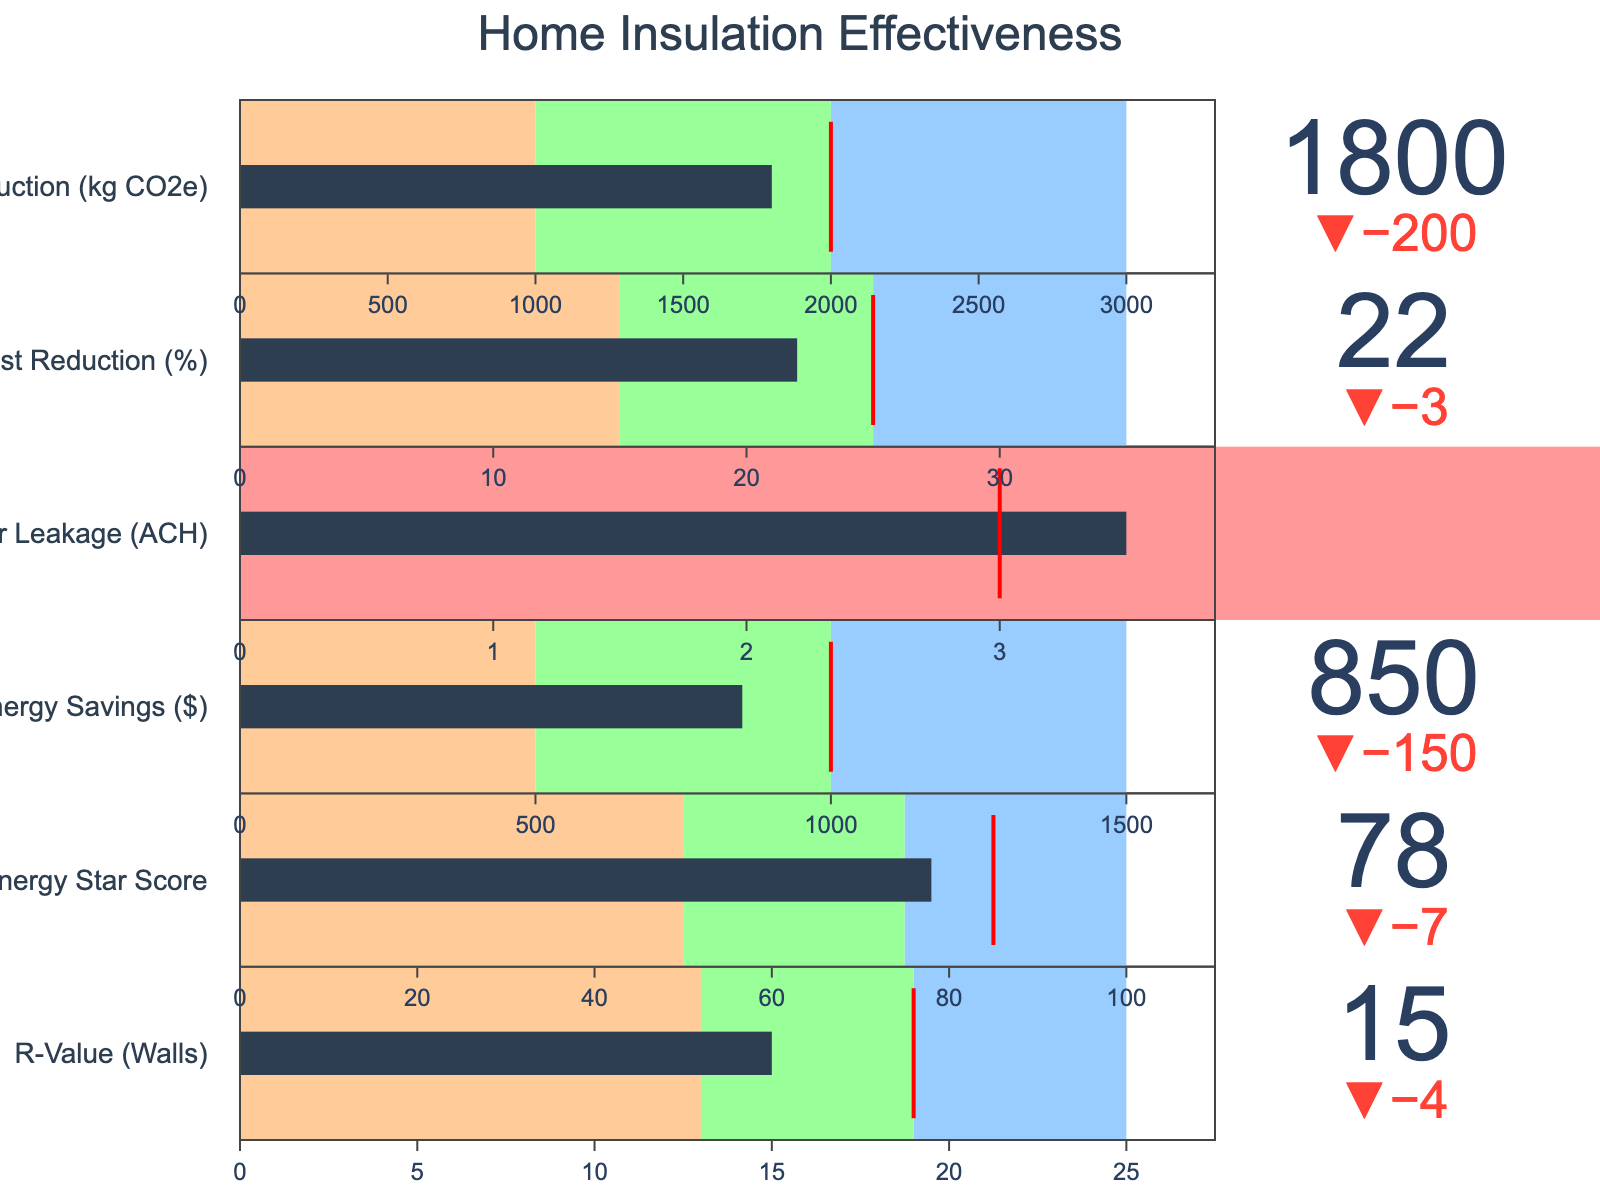What is the target R-Value for the walls? The R-Value (Walls) bar in the bullet chart has a labeled target value. By checking the figure, we can see this value.
Answer: 19 Which metric shows the greatest discrepancy between actual and target values? Compare the delta between the actual and target values for each metric shown in the bullet chart. The metric with the largest difference would have the greatest discrepancy.
Answer: Annual Energy Savings ($) Is the Actual Carbon Footprint Reduction within the 'Good' range? 'Good' range for Carbon Footprint Reduction is between 2000 and 3000 kg CO2e. Checking the value of 1800 kg CO2e falls outside for the 'Good' range.
Answer: No How much higher is the Actual Heating Cost Reduction percentage compared to the 'Average' range maximum? The Actual Heating Cost Reduction percentage is 22%. The 'Average' range maximum is 15%. The difference between these values is 22 - 15 = 7%.
Answer: 7 Does the Actual Air Leakage (ACH) value meet the Target? The target Air Leakage (ACH) is 3, and the actual value is 3.5. Since 3.5 is higher than 3, it does not meet the target.
Answer: No Which metric has the best actual performance when compared to its target? Evaluate which metric is closest to or exceeds its target. The values and delta indications on each bar make this clear.
Answer: Energy Star Score What color step does the Actual Annual Energy Savings fall into? The Actual Annual Energy Savings ($) value is 850. The ranges for the color steps are 0-500 (red), 500-1000 (orange), 1000-1500 (green). Based on the values, 850 falls in 500-1000 range.
Answer: Orange Is the R-Value (Walls) actual value closer to its target than the Heating Cost Reduction (%) actual value to its target? Calculate the absolute difference between the actual and target for both R-Value (19-15=4) and Heating Cost Reduction (25-22=3). Compare these two differences to determine which is smaller.
Answer: No Which metric falls short of the 'Average' range? Compare each metric's actual value against the minimum value of the 'Average' range. Metrics falling below this minimum value are the ones not meeting the 'Average' range.
Answer: None How does the Actual Energy Star Score compare to the ranges? The ranges for Energy Star Score are 0-50 (poor), 50-75 (average), 75-100 (good). The actual score is 78 which falls into the 'Good' range.
Answer: Good 